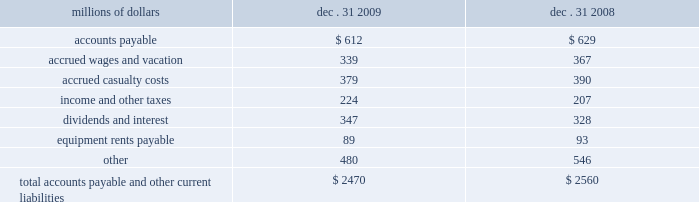Unusual , ( ii ) is material in amount , and ( iii ) varies significantly from the retirement profile identified through our depreciation studies .
A gain or loss is recognized in other income when we sell land or dispose of assets that are not part of our railroad operations .
When we purchase an asset , we capitalize all costs necessary to make the asset ready for its intended use .
However , many of our assets are self-constructed .
A large portion of our capital expenditures is for replacement of existing road infrastructure assets ( program projects ) , which is typically performed by our employees , and for track line expansion ( capacity projects ) .
Costs that are directly attributable or overhead costs that relate directly to capital projects are capitalized .
Direct costs that are capitalized as part of self-constructed assets include material , labor , and work equipment .
Indirect costs are capitalized if they clearly relate to the construction of the asset .
These costs are allocated using appropriate statistical bases .
General and administrative expenditures are expensed as incurred .
Normal repairs and maintenance are also expensed as incurred , while costs incurred that extend the useful life of an asset , improve the safety of our operations or improve operating efficiency are capitalized .
Assets held under capital leases are recorded at the lower of the net present value of the minimum lease payments or the fair value of the leased asset at the inception of the lease .
Amortization expense is computed using the straight-line method over the shorter of the estimated useful lives of the assets or the period of the related lease .
11 .
Accounts payable and other current liabilities dec .
31 , dec .
31 , millions of dollars 2009 2008 .
12 .
Financial instruments strategy and risk 2013 we may use derivative financial instruments in limited instances for other than trading purposes to assist in managing our overall exposure to fluctuations in interest rates and fuel prices .
We are not a party to leveraged derivatives and , by policy , do not use derivative financial instruments for speculative purposes .
Derivative financial instruments qualifying for hedge accounting must maintain a specified level of effectiveness between the hedging instrument and the item being hedged , both at inception and throughout the hedged period .
We formally document the nature and relationships between the hedging instruments and hedged items at inception , as well as our risk-management objectives , strategies for undertaking the various hedge transactions , and method of assessing hedge effectiveness .
Changes in the fair market value of derivative financial instruments that do not qualify for hedge accounting are charged to earnings .
We may use swaps , collars , futures , and/or forward contracts to mitigate the risk of adverse movements in interest rates and fuel prices ; however , the use of these derivative financial instruments may limit future benefits from favorable interest rate and fuel price movements. .
What was the change in accrued wages and vacation in millions from 2008 to 2009? 
Computations: (339 / 367)
Answer: 0.92371. 